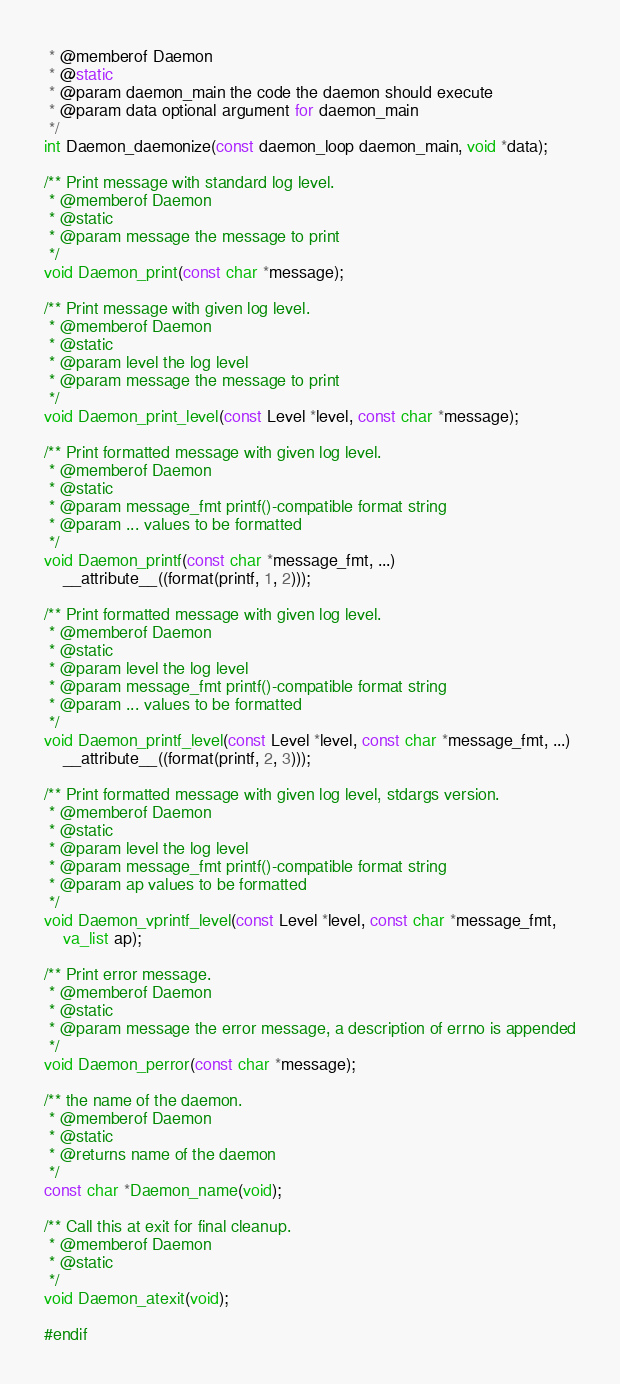Convert code to text. <code><loc_0><loc_0><loc_500><loc_500><_C_> * @memberof Daemon
 * @static
 * @param daemon_main the code the daemon should execute
 * @param data optional argument for daemon_main
 */
int Daemon_daemonize(const daemon_loop daemon_main, void *data);

/** Print message with standard log level.
 * @memberof Daemon
 * @static
 * @param message the message to print
 */
void Daemon_print(const char *message);

/** Print message with given log level.
 * @memberof Daemon
 * @static
 * @param level the log level
 * @param message the message to print
 */
void Daemon_print_level(const Level *level, const char *message);

/** Print formatted message with given log level.
 * @memberof Daemon
 * @static
 * @param message_fmt printf()-compatible format string
 * @param ... values to be formatted
 */
void Daemon_printf(const char *message_fmt, ...)
    __attribute__((format(printf, 1, 2)));

/** Print formatted message with given log level.
 * @memberof Daemon
 * @static
 * @param level the log level
 * @param message_fmt printf()-compatible format string
 * @param ... values to be formatted
 */
void Daemon_printf_level(const Level *level, const char *message_fmt, ...)
    __attribute__((format(printf, 2, 3)));

/** Print formatted message with given log level, stdargs version.
 * @memberof Daemon
 * @static
 * @param level the log level
 * @param message_fmt printf()-compatible format string
 * @param ap values to be formatted
 */
void Daemon_vprintf_level(const Level *level, const char *message_fmt,
	va_list ap);

/** Print error message.
 * @memberof Daemon
 * @static
 * @param message the error message, a description of errno is appended
 */
void Daemon_perror(const char *message);

/** the name of the daemon.
 * @memberof Daemon
 * @static
 * @returns name of the daemon
 */
const char *Daemon_name(void);

/** Call this at exit for final cleanup.
 * @memberof Daemon
 * @static
 */
void Daemon_atexit(void);

#endif

</code> 